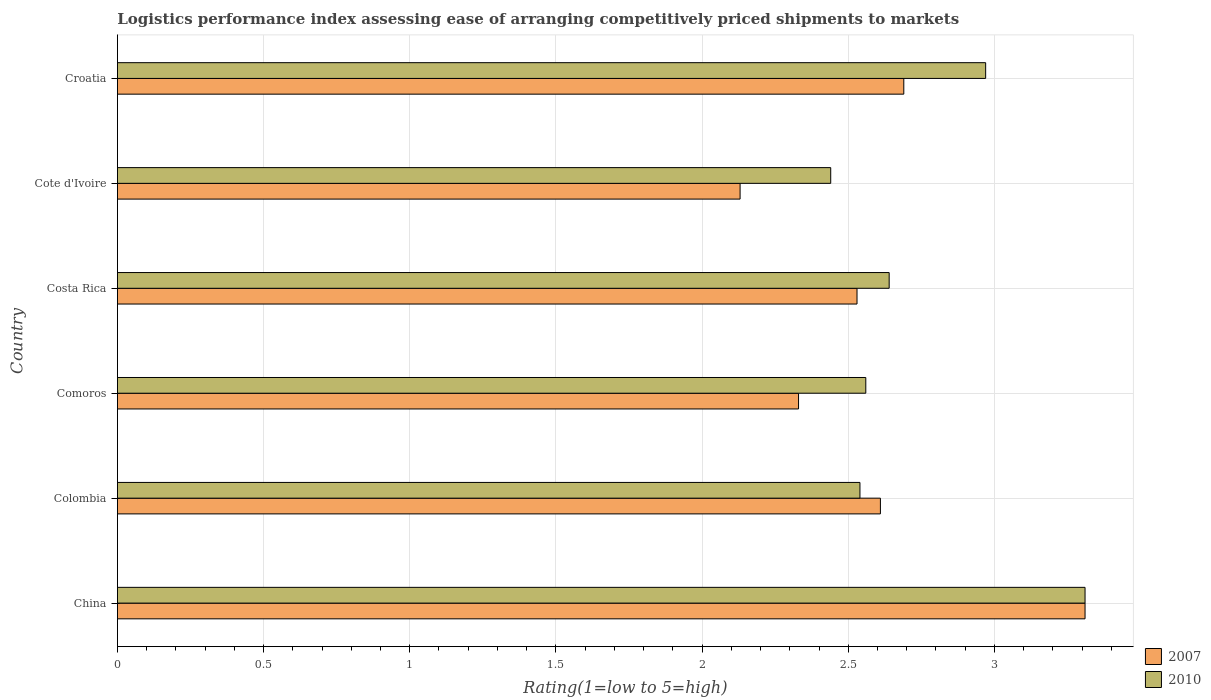How many groups of bars are there?
Offer a terse response. 6. How many bars are there on the 5th tick from the top?
Offer a very short reply. 2. How many bars are there on the 4th tick from the bottom?
Your answer should be very brief. 2. What is the label of the 2nd group of bars from the top?
Make the answer very short. Cote d'Ivoire. What is the Logistic performance index in 2007 in China?
Offer a very short reply. 3.31. Across all countries, what is the maximum Logistic performance index in 2010?
Your response must be concise. 3.31. Across all countries, what is the minimum Logistic performance index in 2007?
Ensure brevity in your answer.  2.13. In which country was the Logistic performance index in 2010 minimum?
Keep it short and to the point. Cote d'Ivoire. What is the total Logistic performance index in 2010 in the graph?
Your response must be concise. 16.46. What is the difference between the Logistic performance index in 2010 in China and that in Colombia?
Provide a succinct answer. 0.77. What is the difference between the Logistic performance index in 2007 in Costa Rica and the Logistic performance index in 2010 in Colombia?
Offer a very short reply. -0.01. What is the average Logistic performance index in 2007 per country?
Offer a terse response. 2.6. What is the difference between the Logistic performance index in 2007 and Logistic performance index in 2010 in Croatia?
Your answer should be very brief. -0.28. What is the ratio of the Logistic performance index in 2007 in Comoros to that in Costa Rica?
Offer a terse response. 0.92. Is the Logistic performance index in 2007 in China less than that in Colombia?
Provide a short and direct response. No. Is the difference between the Logistic performance index in 2007 in Colombia and Croatia greater than the difference between the Logistic performance index in 2010 in Colombia and Croatia?
Offer a very short reply. Yes. What is the difference between the highest and the second highest Logistic performance index in 2010?
Make the answer very short. 0.34. What is the difference between the highest and the lowest Logistic performance index in 2010?
Give a very brief answer. 0.87. In how many countries, is the Logistic performance index in 2010 greater than the average Logistic performance index in 2010 taken over all countries?
Your answer should be compact. 2. What does the 2nd bar from the top in Cote d'Ivoire represents?
Keep it short and to the point. 2007. What does the 1st bar from the bottom in Cote d'Ivoire represents?
Your answer should be very brief. 2007. How many bars are there?
Offer a terse response. 12. How many countries are there in the graph?
Ensure brevity in your answer.  6. Are the values on the major ticks of X-axis written in scientific E-notation?
Make the answer very short. No. Does the graph contain any zero values?
Ensure brevity in your answer.  No. Where does the legend appear in the graph?
Provide a short and direct response. Bottom right. How many legend labels are there?
Provide a succinct answer. 2. How are the legend labels stacked?
Offer a terse response. Vertical. What is the title of the graph?
Give a very brief answer. Logistics performance index assessing ease of arranging competitively priced shipments to markets. What is the label or title of the X-axis?
Provide a succinct answer. Rating(1=low to 5=high). What is the Rating(1=low to 5=high) of 2007 in China?
Provide a succinct answer. 3.31. What is the Rating(1=low to 5=high) of 2010 in China?
Give a very brief answer. 3.31. What is the Rating(1=low to 5=high) in 2007 in Colombia?
Your answer should be compact. 2.61. What is the Rating(1=low to 5=high) in 2010 in Colombia?
Your answer should be compact. 2.54. What is the Rating(1=low to 5=high) in 2007 in Comoros?
Provide a short and direct response. 2.33. What is the Rating(1=low to 5=high) of 2010 in Comoros?
Offer a very short reply. 2.56. What is the Rating(1=low to 5=high) of 2007 in Costa Rica?
Offer a terse response. 2.53. What is the Rating(1=low to 5=high) of 2010 in Costa Rica?
Offer a terse response. 2.64. What is the Rating(1=low to 5=high) of 2007 in Cote d'Ivoire?
Keep it short and to the point. 2.13. What is the Rating(1=low to 5=high) in 2010 in Cote d'Ivoire?
Your answer should be very brief. 2.44. What is the Rating(1=low to 5=high) in 2007 in Croatia?
Provide a succinct answer. 2.69. What is the Rating(1=low to 5=high) in 2010 in Croatia?
Give a very brief answer. 2.97. Across all countries, what is the maximum Rating(1=low to 5=high) in 2007?
Offer a very short reply. 3.31. Across all countries, what is the maximum Rating(1=low to 5=high) of 2010?
Ensure brevity in your answer.  3.31. Across all countries, what is the minimum Rating(1=low to 5=high) in 2007?
Keep it short and to the point. 2.13. Across all countries, what is the minimum Rating(1=low to 5=high) of 2010?
Keep it short and to the point. 2.44. What is the total Rating(1=low to 5=high) of 2007 in the graph?
Offer a very short reply. 15.6. What is the total Rating(1=low to 5=high) in 2010 in the graph?
Keep it short and to the point. 16.46. What is the difference between the Rating(1=low to 5=high) of 2010 in China and that in Colombia?
Make the answer very short. 0.77. What is the difference between the Rating(1=low to 5=high) of 2007 in China and that in Comoros?
Your response must be concise. 0.98. What is the difference between the Rating(1=low to 5=high) of 2007 in China and that in Costa Rica?
Offer a terse response. 0.78. What is the difference between the Rating(1=low to 5=high) in 2010 in China and that in Costa Rica?
Your answer should be very brief. 0.67. What is the difference between the Rating(1=low to 5=high) in 2007 in China and that in Cote d'Ivoire?
Offer a terse response. 1.18. What is the difference between the Rating(1=low to 5=high) in 2010 in China and that in Cote d'Ivoire?
Make the answer very short. 0.87. What is the difference between the Rating(1=low to 5=high) of 2007 in China and that in Croatia?
Give a very brief answer. 0.62. What is the difference between the Rating(1=low to 5=high) in 2010 in China and that in Croatia?
Make the answer very short. 0.34. What is the difference between the Rating(1=low to 5=high) of 2007 in Colombia and that in Comoros?
Ensure brevity in your answer.  0.28. What is the difference between the Rating(1=low to 5=high) in 2010 in Colombia and that in Comoros?
Give a very brief answer. -0.02. What is the difference between the Rating(1=low to 5=high) in 2007 in Colombia and that in Costa Rica?
Your response must be concise. 0.08. What is the difference between the Rating(1=low to 5=high) of 2010 in Colombia and that in Costa Rica?
Provide a succinct answer. -0.1. What is the difference between the Rating(1=low to 5=high) in 2007 in Colombia and that in Cote d'Ivoire?
Your answer should be compact. 0.48. What is the difference between the Rating(1=low to 5=high) in 2010 in Colombia and that in Cote d'Ivoire?
Provide a short and direct response. 0.1. What is the difference between the Rating(1=low to 5=high) in 2007 in Colombia and that in Croatia?
Your answer should be very brief. -0.08. What is the difference between the Rating(1=low to 5=high) of 2010 in Colombia and that in Croatia?
Your response must be concise. -0.43. What is the difference between the Rating(1=low to 5=high) of 2010 in Comoros and that in Costa Rica?
Offer a very short reply. -0.08. What is the difference between the Rating(1=low to 5=high) in 2007 in Comoros and that in Cote d'Ivoire?
Keep it short and to the point. 0.2. What is the difference between the Rating(1=low to 5=high) of 2010 in Comoros and that in Cote d'Ivoire?
Provide a short and direct response. 0.12. What is the difference between the Rating(1=low to 5=high) in 2007 in Comoros and that in Croatia?
Give a very brief answer. -0.36. What is the difference between the Rating(1=low to 5=high) in 2010 in Comoros and that in Croatia?
Make the answer very short. -0.41. What is the difference between the Rating(1=low to 5=high) in 2010 in Costa Rica and that in Cote d'Ivoire?
Your answer should be very brief. 0.2. What is the difference between the Rating(1=low to 5=high) in 2007 in Costa Rica and that in Croatia?
Provide a succinct answer. -0.16. What is the difference between the Rating(1=low to 5=high) of 2010 in Costa Rica and that in Croatia?
Your answer should be compact. -0.33. What is the difference between the Rating(1=low to 5=high) of 2007 in Cote d'Ivoire and that in Croatia?
Give a very brief answer. -0.56. What is the difference between the Rating(1=low to 5=high) in 2010 in Cote d'Ivoire and that in Croatia?
Give a very brief answer. -0.53. What is the difference between the Rating(1=low to 5=high) in 2007 in China and the Rating(1=low to 5=high) in 2010 in Colombia?
Your answer should be compact. 0.77. What is the difference between the Rating(1=low to 5=high) in 2007 in China and the Rating(1=low to 5=high) in 2010 in Comoros?
Your answer should be compact. 0.75. What is the difference between the Rating(1=low to 5=high) of 2007 in China and the Rating(1=low to 5=high) of 2010 in Costa Rica?
Provide a short and direct response. 0.67. What is the difference between the Rating(1=low to 5=high) of 2007 in China and the Rating(1=low to 5=high) of 2010 in Cote d'Ivoire?
Your response must be concise. 0.87. What is the difference between the Rating(1=low to 5=high) in 2007 in China and the Rating(1=low to 5=high) in 2010 in Croatia?
Make the answer very short. 0.34. What is the difference between the Rating(1=low to 5=high) in 2007 in Colombia and the Rating(1=low to 5=high) in 2010 in Costa Rica?
Your answer should be very brief. -0.03. What is the difference between the Rating(1=low to 5=high) of 2007 in Colombia and the Rating(1=low to 5=high) of 2010 in Cote d'Ivoire?
Your response must be concise. 0.17. What is the difference between the Rating(1=low to 5=high) in 2007 in Colombia and the Rating(1=low to 5=high) in 2010 in Croatia?
Ensure brevity in your answer.  -0.36. What is the difference between the Rating(1=low to 5=high) of 2007 in Comoros and the Rating(1=low to 5=high) of 2010 in Costa Rica?
Your answer should be compact. -0.31. What is the difference between the Rating(1=low to 5=high) in 2007 in Comoros and the Rating(1=low to 5=high) in 2010 in Cote d'Ivoire?
Your answer should be compact. -0.11. What is the difference between the Rating(1=low to 5=high) of 2007 in Comoros and the Rating(1=low to 5=high) of 2010 in Croatia?
Give a very brief answer. -0.64. What is the difference between the Rating(1=low to 5=high) of 2007 in Costa Rica and the Rating(1=low to 5=high) of 2010 in Cote d'Ivoire?
Your answer should be very brief. 0.09. What is the difference between the Rating(1=low to 5=high) in 2007 in Costa Rica and the Rating(1=low to 5=high) in 2010 in Croatia?
Offer a very short reply. -0.44. What is the difference between the Rating(1=low to 5=high) in 2007 in Cote d'Ivoire and the Rating(1=low to 5=high) in 2010 in Croatia?
Give a very brief answer. -0.84. What is the average Rating(1=low to 5=high) in 2010 per country?
Offer a terse response. 2.74. What is the difference between the Rating(1=low to 5=high) in 2007 and Rating(1=low to 5=high) in 2010 in China?
Provide a succinct answer. 0. What is the difference between the Rating(1=low to 5=high) in 2007 and Rating(1=low to 5=high) in 2010 in Colombia?
Offer a very short reply. 0.07. What is the difference between the Rating(1=low to 5=high) of 2007 and Rating(1=low to 5=high) of 2010 in Comoros?
Provide a succinct answer. -0.23. What is the difference between the Rating(1=low to 5=high) in 2007 and Rating(1=low to 5=high) in 2010 in Costa Rica?
Provide a succinct answer. -0.11. What is the difference between the Rating(1=low to 5=high) of 2007 and Rating(1=low to 5=high) of 2010 in Cote d'Ivoire?
Give a very brief answer. -0.31. What is the difference between the Rating(1=low to 5=high) in 2007 and Rating(1=low to 5=high) in 2010 in Croatia?
Give a very brief answer. -0.28. What is the ratio of the Rating(1=low to 5=high) of 2007 in China to that in Colombia?
Offer a terse response. 1.27. What is the ratio of the Rating(1=low to 5=high) of 2010 in China to that in Colombia?
Provide a short and direct response. 1.3. What is the ratio of the Rating(1=low to 5=high) in 2007 in China to that in Comoros?
Keep it short and to the point. 1.42. What is the ratio of the Rating(1=low to 5=high) of 2010 in China to that in Comoros?
Provide a succinct answer. 1.29. What is the ratio of the Rating(1=low to 5=high) of 2007 in China to that in Costa Rica?
Provide a short and direct response. 1.31. What is the ratio of the Rating(1=low to 5=high) of 2010 in China to that in Costa Rica?
Your answer should be very brief. 1.25. What is the ratio of the Rating(1=low to 5=high) of 2007 in China to that in Cote d'Ivoire?
Make the answer very short. 1.55. What is the ratio of the Rating(1=low to 5=high) in 2010 in China to that in Cote d'Ivoire?
Give a very brief answer. 1.36. What is the ratio of the Rating(1=low to 5=high) of 2007 in China to that in Croatia?
Offer a terse response. 1.23. What is the ratio of the Rating(1=low to 5=high) of 2010 in China to that in Croatia?
Your answer should be very brief. 1.11. What is the ratio of the Rating(1=low to 5=high) of 2007 in Colombia to that in Comoros?
Give a very brief answer. 1.12. What is the ratio of the Rating(1=low to 5=high) in 2010 in Colombia to that in Comoros?
Provide a short and direct response. 0.99. What is the ratio of the Rating(1=low to 5=high) of 2007 in Colombia to that in Costa Rica?
Offer a terse response. 1.03. What is the ratio of the Rating(1=low to 5=high) of 2010 in Colombia to that in Costa Rica?
Your response must be concise. 0.96. What is the ratio of the Rating(1=low to 5=high) in 2007 in Colombia to that in Cote d'Ivoire?
Keep it short and to the point. 1.23. What is the ratio of the Rating(1=low to 5=high) in 2010 in Colombia to that in Cote d'Ivoire?
Make the answer very short. 1.04. What is the ratio of the Rating(1=low to 5=high) in 2007 in Colombia to that in Croatia?
Provide a succinct answer. 0.97. What is the ratio of the Rating(1=low to 5=high) in 2010 in Colombia to that in Croatia?
Your answer should be very brief. 0.86. What is the ratio of the Rating(1=low to 5=high) of 2007 in Comoros to that in Costa Rica?
Give a very brief answer. 0.92. What is the ratio of the Rating(1=low to 5=high) of 2010 in Comoros to that in Costa Rica?
Make the answer very short. 0.97. What is the ratio of the Rating(1=low to 5=high) in 2007 in Comoros to that in Cote d'Ivoire?
Offer a terse response. 1.09. What is the ratio of the Rating(1=low to 5=high) in 2010 in Comoros to that in Cote d'Ivoire?
Keep it short and to the point. 1.05. What is the ratio of the Rating(1=low to 5=high) of 2007 in Comoros to that in Croatia?
Make the answer very short. 0.87. What is the ratio of the Rating(1=low to 5=high) of 2010 in Comoros to that in Croatia?
Your response must be concise. 0.86. What is the ratio of the Rating(1=low to 5=high) of 2007 in Costa Rica to that in Cote d'Ivoire?
Give a very brief answer. 1.19. What is the ratio of the Rating(1=low to 5=high) of 2010 in Costa Rica to that in Cote d'Ivoire?
Ensure brevity in your answer.  1.08. What is the ratio of the Rating(1=low to 5=high) of 2007 in Costa Rica to that in Croatia?
Ensure brevity in your answer.  0.94. What is the ratio of the Rating(1=low to 5=high) of 2010 in Costa Rica to that in Croatia?
Ensure brevity in your answer.  0.89. What is the ratio of the Rating(1=low to 5=high) of 2007 in Cote d'Ivoire to that in Croatia?
Your answer should be compact. 0.79. What is the ratio of the Rating(1=low to 5=high) in 2010 in Cote d'Ivoire to that in Croatia?
Your answer should be very brief. 0.82. What is the difference between the highest and the second highest Rating(1=low to 5=high) of 2007?
Ensure brevity in your answer.  0.62. What is the difference between the highest and the second highest Rating(1=low to 5=high) in 2010?
Your response must be concise. 0.34. What is the difference between the highest and the lowest Rating(1=low to 5=high) in 2007?
Your response must be concise. 1.18. What is the difference between the highest and the lowest Rating(1=low to 5=high) in 2010?
Your answer should be very brief. 0.87. 